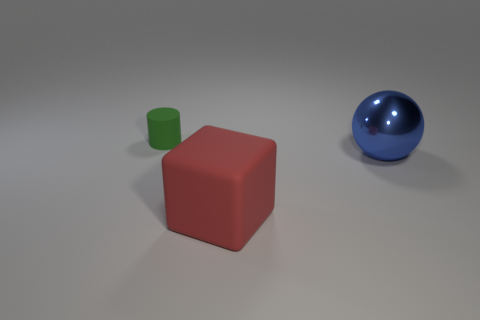Is the size of the rubber object to the left of the cube the same as the big red object?
Ensure brevity in your answer.  No. How many balls are small green things or red rubber objects?
Your answer should be compact. 0. There is a object to the left of the big red matte cube; what is its material?
Offer a very short reply. Rubber. Are there fewer big blue metal balls than small yellow rubber things?
Give a very brief answer. No. There is a object that is both left of the metal object and to the right of the green matte cylinder; what is its size?
Your response must be concise. Large. There is a object that is to the right of the rubber thing that is in front of the rubber object behind the big blue shiny object; what is its size?
Make the answer very short. Large. What number of other things are there of the same color as the small matte object?
Keep it short and to the point. 0. There is a rubber object in front of the tiny green matte object; does it have the same color as the metal sphere?
Provide a short and direct response. No. How many things are tiny blue matte objects or big matte objects?
Give a very brief answer. 1. There is a big object to the right of the red rubber thing; what is its color?
Your response must be concise. Blue. 